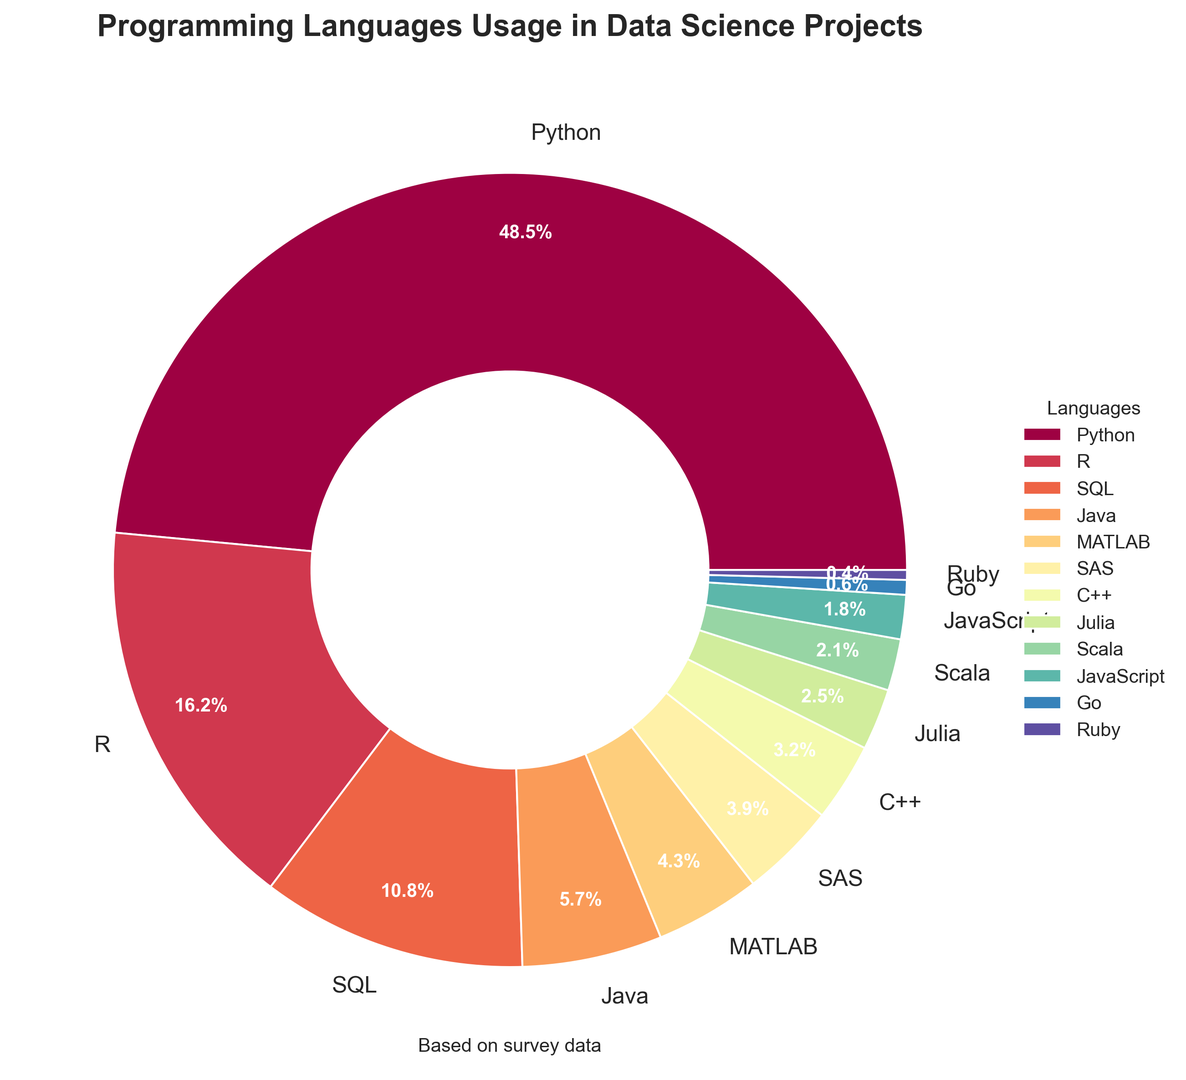What percentage of data science projects use R and SQL combined? To find the combined usage percentage of R and SQL in data science projects, look at the pie chart and find the respective percentages for R (16.2%) and SQL (10.8%). Add these two percentages together: 16.2% + 10.8% = 27.0%.
Answer: 27.0% Which language is used less frequently: Scala or MATLAB? To compare the usage frequencies of Scala and MATLAB, find their respective percentages on the pie chart. MATLAB is used in 4.3% of projects, and Scala is used in 2.1%. Thus, Scala is used less frequently than MATLAB.
Answer: Scala How much more frequently is Python used compared to Java? To determine how much more frequently Python is used compared to Java, find the percentages for both: Python (48.5%) and Java (5.7%). Subtract Java's percentage from Python's percentage: 48.5% - 5.7% = 42.8%.
Answer: 42.8% Which programming language represents the smallest proportion of usage and what is its percentage? To find the language with the smallest proportion, look at the pie chart's wedges and the corresponding percentages. Ruby has the smallest percentage at 0.4%.
Answer: Ruby, 0.4% Is the combined percentage of usage for Julia and Go greater than that for C++? First, find the percentages for Julia (2.5%), Go (0.6%), and C++ (3.2%) from the pie chart. Add the percentages of Julia and Go: 2.5% + 0.6% = 3.1%. Compare this with C++'s percentage (3.2%). 3.1% is less than 3.2%.
Answer: No Which languages have a usage percentage between 1% to 10% inclusive? Examine the pie chart and list the languages whose wedges fall in the usage percentage range of 1% to 10% inclusively. These languages are SQL (10.8%), Java (5.7%), MATLAB (4.3%), SAS (3.9%), C++ (3.2%), Julia (2.5%), Scala (2.1%), JavaScript (1.8%).
Answer: SQL, Java, MATLAB, SAS, C++, Julia, Scala, JavaScript What is the total percentage of usage for all the languages other than Python? To find the total percentage for all languages other than Python, sum up the percentages of the other languages: R (16.2%), SQL (10.8%), Java (5.7%), MATLAB (4.3%), SAS (3.9%), C++ (3.2%), Julia (2.5%), Scala (2.1%), JavaScript (1.8%), Go (0.6%), Ruby (0.4%). The sum is 51.5%.
Answer: 51.5% What is the average usage percentage for SAS, C++, and Go? To calculate the average usage percentage for SAS, C++, and Go, first find their percentages: SAS (3.9%), C++ (3.2%), Go (0.6%). Add these percentages together: 3.9% + 3.2% + 0.6% = 7.7%. Divide by the number of languages (3): 7.7% / 3 = 2.57%.
Answer: 2.57% What is the difference in percentage points between the most used language and the least used language? Determine the most used language (Python, 48.5%) and the least used language (Ruby, 0.4%), then subtract the percentage of the least used language from the most used language: 48.5% - 0.4% = 48.1%.
Answer: 48.1% 